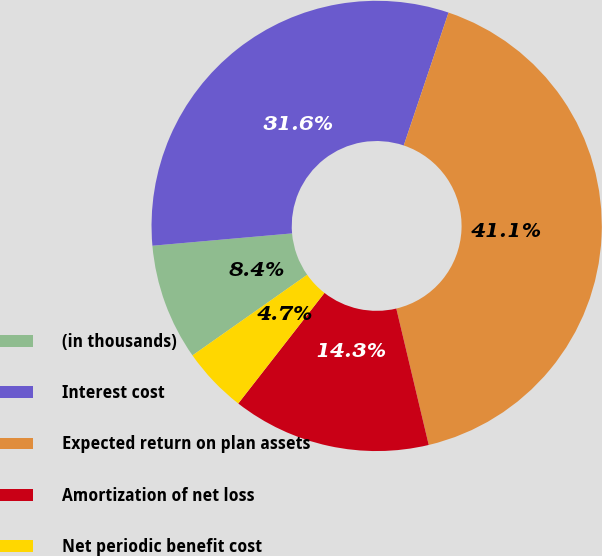<chart> <loc_0><loc_0><loc_500><loc_500><pie_chart><fcel>(in thousands)<fcel>Interest cost<fcel>Expected return on plan assets<fcel>Amortization of net loss<fcel>Net periodic benefit cost<nl><fcel>8.35%<fcel>31.57%<fcel>41.11%<fcel>14.25%<fcel>4.71%<nl></chart> 